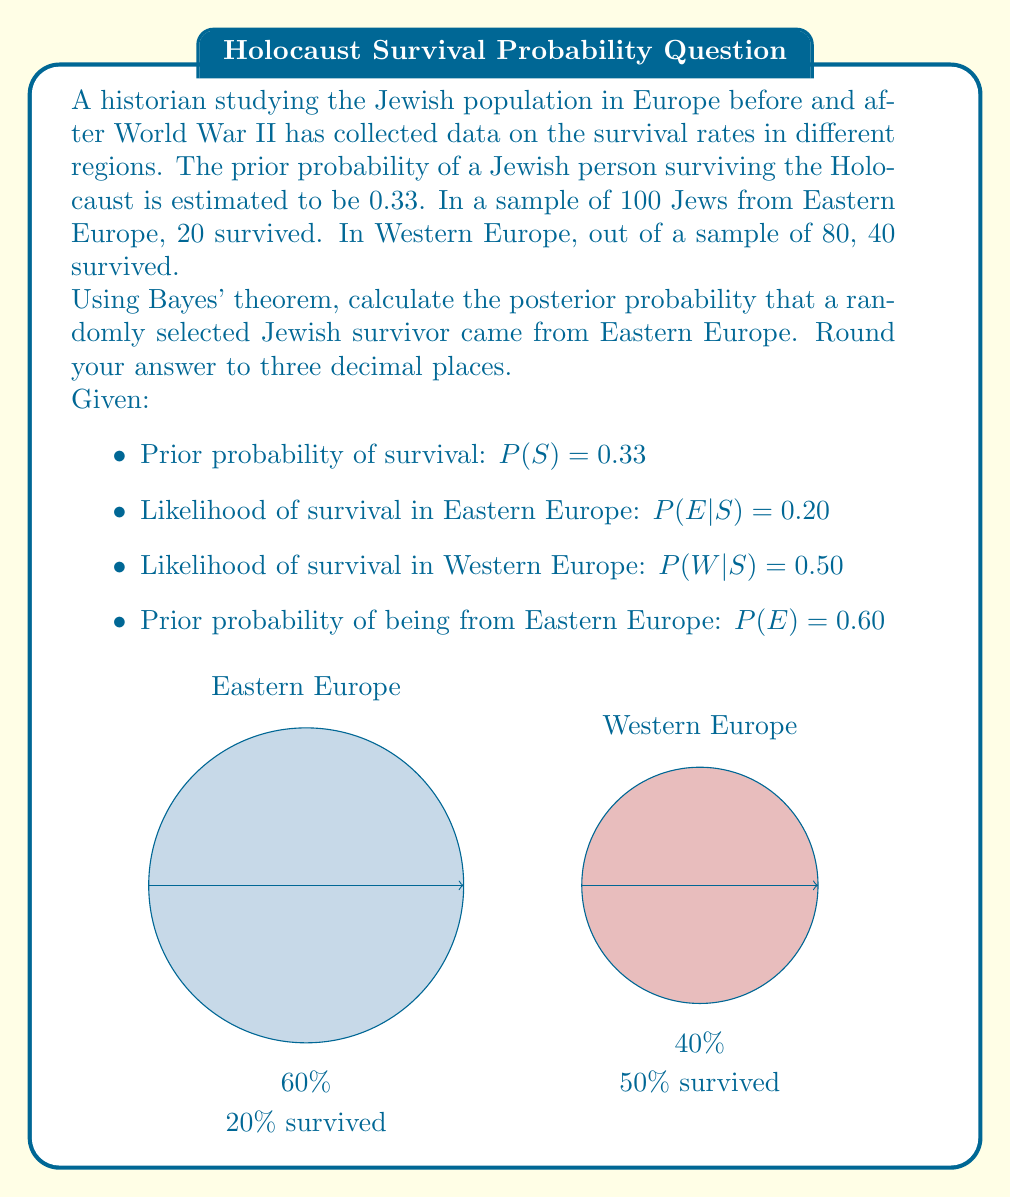Can you solve this math problem? To solve this problem, we'll use Bayes' theorem:

$$P(E|S) = \frac{P(S|E) \cdot P(E)}{P(S)}$$

Where:
$E$ = Event of being from Eastern Europe
$S$ = Event of surviving

Step 1: Calculate $P(S|E)$ (likelihood of survival given Eastern Europe)
We're given $P(E|S) = 0.20$, but we need $P(S|E)$. We can use Bayes' theorem to find this:

$$P(S|E) = \frac{P(E|S) \cdot P(S)}{P(E)} = \frac{0.20 \cdot 0.33}{0.60} = 0.11$$

Step 2: Calculate $P(S)$ (total probability of survival)
$P(S) = P(S|E) \cdot P(E) + P(S|W) \cdot P(W)$
$P(S) = 0.11 \cdot 0.60 + 0.50 \cdot 0.40 = 0.266$

Step 3: Apply Bayes' theorem
$$P(E|S) = \frac{P(S|E) \cdot P(E)}{P(S)} = \frac{0.11 \cdot 0.60}{0.266} = 0.248$$

Step 4: Round to three decimal places
0.248 rounds to 0.248
Answer: 0.248 